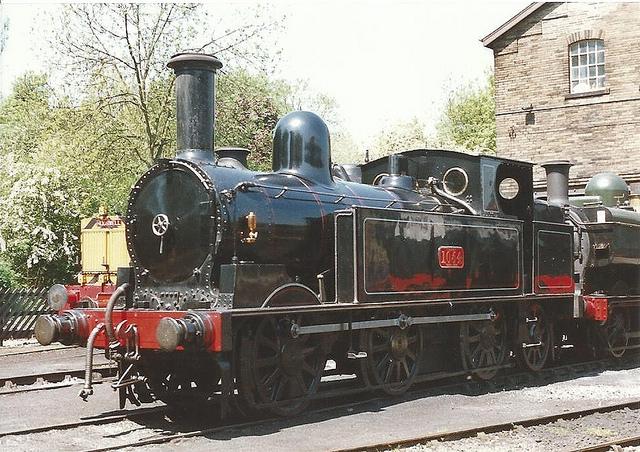Do you see any buildings?
Quick response, please. Yes. What color is the bumper on the train engine?
Write a very short answer. Red. What powers this engine?
Concise answer only. Steam. Is this locomotive an antique?
Write a very short answer. Yes. Is it a bright sunny day?
Answer briefly. Yes. 